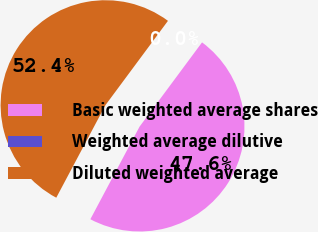<chart> <loc_0><loc_0><loc_500><loc_500><pie_chart><fcel>Basic weighted average shares<fcel>Weighted average dilutive<fcel>Diluted weighted average<nl><fcel>47.62%<fcel>0.0%<fcel>52.38%<nl></chart> 